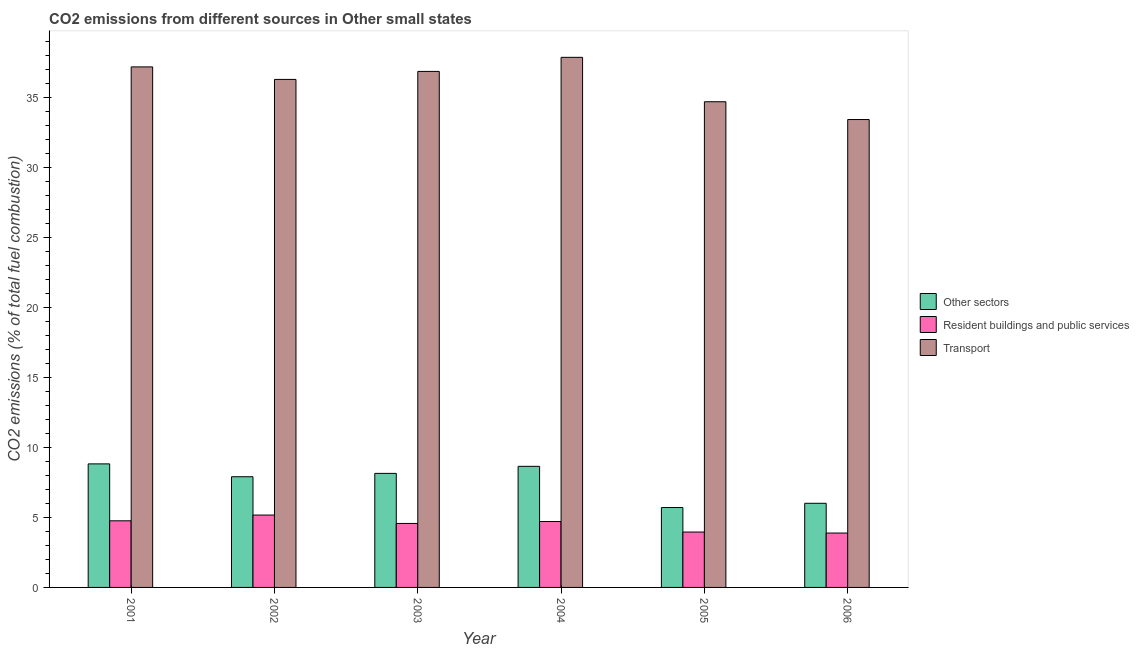How many bars are there on the 1st tick from the left?
Offer a very short reply. 3. What is the label of the 6th group of bars from the left?
Keep it short and to the point. 2006. What is the percentage of co2 emissions from resident buildings and public services in 2003?
Ensure brevity in your answer.  4.57. Across all years, what is the maximum percentage of co2 emissions from other sectors?
Provide a short and direct response. 8.82. Across all years, what is the minimum percentage of co2 emissions from transport?
Offer a terse response. 33.41. In which year was the percentage of co2 emissions from transport maximum?
Your answer should be compact. 2004. In which year was the percentage of co2 emissions from other sectors minimum?
Ensure brevity in your answer.  2005. What is the total percentage of co2 emissions from other sectors in the graph?
Ensure brevity in your answer.  45.22. What is the difference between the percentage of co2 emissions from other sectors in 2002 and that in 2005?
Your response must be concise. 2.2. What is the difference between the percentage of co2 emissions from resident buildings and public services in 2001 and the percentage of co2 emissions from transport in 2005?
Provide a succinct answer. 0.8. What is the average percentage of co2 emissions from transport per year?
Ensure brevity in your answer.  36.04. What is the ratio of the percentage of co2 emissions from resident buildings and public services in 2004 to that in 2006?
Your response must be concise. 1.21. Is the difference between the percentage of co2 emissions from resident buildings and public services in 2003 and 2004 greater than the difference between the percentage of co2 emissions from other sectors in 2003 and 2004?
Your answer should be very brief. No. What is the difference between the highest and the second highest percentage of co2 emissions from other sectors?
Offer a very short reply. 0.18. What is the difference between the highest and the lowest percentage of co2 emissions from other sectors?
Your response must be concise. 3.12. Is the sum of the percentage of co2 emissions from transport in 2002 and 2004 greater than the maximum percentage of co2 emissions from other sectors across all years?
Provide a short and direct response. Yes. What does the 3rd bar from the left in 2001 represents?
Give a very brief answer. Transport. What does the 2nd bar from the right in 2001 represents?
Keep it short and to the point. Resident buildings and public services. Are all the bars in the graph horizontal?
Provide a succinct answer. No. Are the values on the major ticks of Y-axis written in scientific E-notation?
Offer a very short reply. No. Where does the legend appear in the graph?
Your answer should be compact. Center right. What is the title of the graph?
Make the answer very short. CO2 emissions from different sources in Other small states. Does "Taxes on international trade" appear as one of the legend labels in the graph?
Provide a short and direct response. No. What is the label or title of the X-axis?
Provide a succinct answer. Year. What is the label or title of the Y-axis?
Provide a succinct answer. CO2 emissions (% of total fuel combustion). What is the CO2 emissions (% of total fuel combustion) of Other sectors in 2001?
Make the answer very short. 8.82. What is the CO2 emissions (% of total fuel combustion) of Resident buildings and public services in 2001?
Make the answer very short. 4.76. What is the CO2 emissions (% of total fuel combustion) of Transport in 2001?
Your answer should be very brief. 37.17. What is the CO2 emissions (% of total fuel combustion) of Other sectors in 2002?
Provide a short and direct response. 7.9. What is the CO2 emissions (% of total fuel combustion) in Resident buildings and public services in 2002?
Make the answer very short. 5.17. What is the CO2 emissions (% of total fuel combustion) in Transport in 2002?
Keep it short and to the point. 36.27. What is the CO2 emissions (% of total fuel combustion) of Other sectors in 2003?
Your answer should be compact. 8.14. What is the CO2 emissions (% of total fuel combustion) of Resident buildings and public services in 2003?
Offer a terse response. 4.57. What is the CO2 emissions (% of total fuel combustion) of Transport in 2003?
Keep it short and to the point. 36.84. What is the CO2 emissions (% of total fuel combustion) in Other sectors in 2004?
Your response must be concise. 8.65. What is the CO2 emissions (% of total fuel combustion) in Resident buildings and public services in 2004?
Your response must be concise. 4.71. What is the CO2 emissions (% of total fuel combustion) of Transport in 2004?
Keep it short and to the point. 37.85. What is the CO2 emissions (% of total fuel combustion) of Other sectors in 2005?
Offer a terse response. 5.7. What is the CO2 emissions (% of total fuel combustion) in Resident buildings and public services in 2005?
Your answer should be very brief. 3.95. What is the CO2 emissions (% of total fuel combustion) in Transport in 2005?
Provide a short and direct response. 34.68. What is the CO2 emissions (% of total fuel combustion) of Other sectors in 2006?
Provide a succinct answer. 6.01. What is the CO2 emissions (% of total fuel combustion) in Resident buildings and public services in 2006?
Offer a terse response. 3.88. What is the CO2 emissions (% of total fuel combustion) in Transport in 2006?
Offer a terse response. 33.41. Across all years, what is the maximum CO2 emissions (% of total fuel combustion) of Other sectors?
Offer a terse response. 8.82. Across all years, what is the maximum CO2 emissions (% of total fuel combustion) of Resident buildings and public services?
Offer a terse response. 5.17. Across all years, what is the maximum CO2 emissions (% of total fuel combustion) in Transport?
Your answer should be very brief. 37.85. Across all years, what is the minimum CO2 emissions (% of total fuel combustion) of Other sectors?
Make the answer very short. 5.7. Across all years, what is the minimum CO2 emissions (% of total fuel combustion) in Resident buildings and public services?
Ensure brevity in your answer.  3.88. Across all years, what is the minimum CO2 emissions (% of total fuel combustion) in Transport?
Your answer should be compact. 33.41. What is the total CO2 emissions (% of total fuel combustion) in Other sectors in the graph?
Give a very brief answer. 45.22. What is the total CO2 emissions (% of total fuel combustion) in Resident buildings and public services in the graph?
Offer a very short reply. 27.04. What is the total CO2 emissions (% of total fuel combustion) in Transport in the graph?
Your answer should be very brief. 216.21. What is the difference between the CO2 emissions (% of total fuel combustion) of Other sectors in 2001 and that in 2002?
Offer a terse response. 0.92. What is the difference between the CO2 emissions (% of total fuel combustion) of Resident buildings and public services in 2001 and that in 2002?
Keep it short and to the point. -0.41. What is the difference between the CO2 emissions (% of total fuel combustion) in Transport in 2001 and that in 2002?
Your answer should be compact. 0.89. What is the difference between the CO2 emissions (% of total fuel combustion) in Other sectors in 2001 and that in 2003?
Make the answer very short. 0.68. What is the difference between the CO2 emissions (% of total fuel combustion) in Resident buildings and public services in 2001 and that in 2003?
Make the answer very short. 0.19. What is the difference between the CO2 emissions (% of total fuel combustion) in Transport in 2001 and that in 2003?
Keep it short and to the point. 0.32. What is the difference between the CO2 emissions (% of total fuel combustion) in Other sectors in 2001 and that in 2004?
Give a very brief answer. 0.18. What is the difference between the CO2 emissions (% of total fuel combustion) of Resident buildings and public services in 2001 and that in 2004?
Make the answer very short. 0.05. What is the difference between the CO2 emissions (% of total fuel combustion) in Transport in 2001 and that in 2004?
Keep it short and to the point. -0.68. What is the difference between the CO2 emissions (% of total fuel combustion) in Other sectors in 2001 and that in 2005?
Offer a very short reply. 3.12. What is the difference between the CO2 emissions (% of total fuel combustion) in Resident buildings and public services in 2001 and that in 2005?
Ensure brevity in your answer.  0.8. What is the difference between the CO2 emissions (% of total fuel combustion) of Transport in 2001 and that in 2005?
Offer a terse response. 2.49. What is the difference between the CO2 emissions (% of total fuel combustion) of Other sectors in 2001 and that in 2006?
Offer a terse response. 2.81. What is the difference between the CO2 emissions (% of total fuel combustion) of Resident buildings and public services in 2001 and that in 2006?
Provide a succinct answer. 0.87. What is the difference between the CO2 emissions (% of total fuel combustion) of Transport in 2001 and that in 2006?
Your answer should be very brief. 3.76. What is the difference between the CO2 emissions (% of total fuel combustion) in Other sectors in 2002 and that in 2003?
Provide a short and direct response. -0.24. What is the difference between the CO2 emissions (% of total fuel combustion) of Resident buildings and public services in 2002 and that in 2003?
Your answer should be very brief. 0.6. What is the difference between the CO2 emissions (% of total fuel combustion) in Transport in 2002 and that in 2003?
Provide a short and direct response. -0.57. What is the difference between the CO2 emissions (% of total fuel combustion) of Other sectors in 2002 and that in 2004?
Provide a succinct answer. -0.74. What is the difference between the CO2 emissions (% of total fuel combustion) of Resident buildings and public services in 2002 and that in 2004?
Keep it short and to the point. 0.46. What is the difference between the CO2 emissions (% of total fuel combustion) in Transport in 2002 and that in 2004?
Provide a succinct answer. -1.58. What is the difference between the CO2 emissions (% of total fuel combustion) in Other sectors in 2002 and that in 2005?
Make the answer very short. 2.2. What is the difference between the CO2 emissions (% of total fuel combustion) of Resident buildings and public services in 2002 and that in 2005?
Your response must be concise. 1.21. What is the difference between the CO2 emissions (% of total fuel combustion) of Transport in 2002 and that in 2005?
Keep it short and to the point. 1.59. What is the difference between the CO2 emissions (% of total fuel combustion) of Other sectors in 2002 and that in 2006?
Give a very brief answer. 1.9. What is the difference between the CO2 emissions (% of total fuel combustion) of Resident buildings and public services in 2002 and that in 2006?
Give a very brief answer. 1.28. What is the difference between the CO2 emissions (% of total fuel combustion) in Transport in 2002 and that in 2006?
Your response must be concise. 2.86. What is the difference between the CO2 emissions (% of total fuel combustion) of Other sectors in 2003 and that in 2004?
Make the answer very short. -0.5. What is the difference between the CO2 emissions (% of total fuel combustion) in Resident buildings and public services in 2003 and that in 2004?
Keep it short and to the point. -0.14. What is the difference between the CO2 emissions (% of total fuel combustion) in Transport in 2003 and that in 2004?
Your answer should be compact. -1.01. What is the difference between the CO2 emissions (% of total fuel combustion) in Other sectors in 2003 and that in 2005?
Offer a terse response. 2.44. What is the difference between the CO2 emissions (% of total fuel combustion) in Resident buildings and public services in 2003 and that in 2005?
Ensure brevity in your answer.  0.61. What is the difference between the CO2 emissions (% of total fuel combustion) of Transport in 2003 and that in 2005?
Offer a very short reply. 2.17. What is the difference between the CO2 emissions (% of total fuel combustion) in Other sectors in 2003 and that in 2006?
Make the answer very short. 2.14. What is the difference between the CO2 emissions (% of total fuel combustion) in Resident buildings and public services in 2003 and that in 2006?
Your answer should be very brief. 0.69. What is the difference between the CO2 emissions (% of total fuel combustion) in Transport in 2003 and that in 2006?
Offer a terse response. 3.44. What is the difference between the CO2 emissions (% of total fuel combustion) of Other sectors in 2004 and that in 2005?
Your response must be concise. 2.94. What is the difference between the CO2 emissions (% of total fuel combustion) of Resident buildings and public services in 2004 and that in 2005?
Keep it short and to the point. 0.75. What is the difference between the CO2 emissions (% of total fuel combustion) in Transport in 2004 and that in 2005?
Provide a short and direct response. 3.17. What is the difference between the CO2 emissions (% of total fuel combustion) in Other sectors in 2004 and that in 2006?
Your response must be concise. 2.64. What is the difference between the CO2 emissions (% of total fuel combustion) in Resident buildings and public services in 2004 and that in 2006?
Your answer should be very brief. 0.82. What is the difference between the CO2 emissions (% of total fuel combustion) of Transport in 2004 and that in 2006?
Offer a terse response. 4.44. What is the difference between the CO2 emissions (% of total fuel combustion) in Other sectors in 2005 and that in 2006?
Give a very brief answer. -0.3. What is the difference between the CO2 emissions (% of total fuel combustion) of Resident buildings and public services in 2005 and that in 2006?
Give a very brief answer. 0.07. What is the difference between the CO2 emissions (% of total fuel combustion) in Transport in 2005 and that in 2006?
Make the answer very short. 1.27. What is the difference between the CO2 emissions (% of total fuel combustion) in Other sectors in 2001 and the CO2 emissions (% of total fuel combustion) in Resident buildings and public services in 2002?
Provide a short and direct response. 3.65. What is the difference between the CO2 emissions (% of total fuel combustion) in Other sectors in 2001 and the CO2 emissions (% of total fuel combustion) in Transport in 2002?
Your answer should be very brief. -27.45. What is the difference between the CO2 emissions (% of total fuel combustion) of Resident buildings and public services in 2001 and the CO2 emissions (% of total fuel combustion) of Transport in 2002?
Provide a succinct answer. -31.51. What is the difference between the CO2 emissions (% of total fuel combustion) of Other sectors in 2001 and the CO2 emissions (% of total fuel combustion) of Resident buildings and public services in 2003?
Your answer should be compact. 4.25. What is the difference between the CO2 emissions (% of total fuel combustion) in Other sectors in 2001 and the CO2 emissions (% of total fuel combustion) in Transport in 2003?
Your answer should be very brief. -28.02. What is the difference between the CO2 emissions (% of total fuel combustion) of Resident buildings and public services in 2001 and the CO2 emissions (% of total fuel combustion) of Transport in 2003?
Your response must be concise. -32.08. What is the difference between the CO2 emissions (% of total fuel combustion) of Other sectors in 2001 and the CO2 emissions (% of total fuel combustion) of Resident buildings and public services in 2004?
Offer a terse response. 4.11. What is the difference between the CO2 emissions (% of total fuel combustion) in Other sectors in 2001 and the CO2 emissions (% of total fuel combustion) in Transport in 2004?
Your answer should be compact. -29.03. What is the difference between the CO2 emissions (% of total fuel combustion) of Resident buildings and public services in 2001 and the CO2 emissions (% of total fuel combustion) of Transport in 2004?
Make the answer very short. -33.09. What is the difference between the CO2 emissions (% of total fuel combustion) of Other sectors in 2001 and the CO2 emissions (% of total fuel combustion) of Resident buildings and public services in 2005?
Your answer should be very brief. 4.87. What is the difference between the CO2 emissions (% of total fuel combustion) of Other sectors in 2001 and the CO2 emissions (% of total fuel combustion) of Transport in 2005?
Provide a succinct answer. -25.86. What is the difference between the CO2 emissions (% of total fuel combustion) of Resident buildings and public services in 2001 and the CO2 emissions (% of total fuel combustion) of Transport in 2005?
Give a very brief answer. -29.92. What is the difference between the CO2 emissions (% of total fuel combustion) in Other sectors in 2001 and the CO2 emissions (% of total fuel combustion) in Resident buildings and public services in 2006?
Your answer should be very brief. 4.94. What is the difference between the CO2 emissions (% of total fuel combustion) of Other sectors in 2001 and the CO2 emissions (% of total fuel combustion) of Transport in 2006?
Offer a terse response. -24.59. What is the difference between the CO2 emissions (% of total fuel combustion) of Resident buildings and public services in 2001 and the CO2 emissions (% of total fuel combustion) of Transport in 2006?
Offer a very short reply. -28.65. What is the difference between the CO2 emissions (% of total fuel combustion) in Other sectors in 2002 and the CO2 emissions (% of total fuel combustion) in Resident buildings and public services in 2003?
Your answer should be compact. 3.33. What is the difference between the CO2 emissions (% of total fuel combustion) of Other sectors in 2002 and the CO2 emissions (% of total fuel combustion) of Transport in 2003?
Your answer should be very brief. -28.94. What is the difference between the CO2 emissions (% of total fuel combustion) in Resident buildings and public services in 2002 and the CO2 emissions (% of total fuel combustion) in Transport in 2003?
Provide a short and direct response. -31.67. What is the difference between the CO2 emissions (% of total fuel combustion) in Other sectors in 2002 and the CO2 emissions (% of total fuel combustion) in Resident buildings and public services in 2004?
Your response must be concise. 3.2. What is the difference between the CO2 emissions (% of total fuel combustion) of Other sectors in 2002 and the CO2 emissions (% of total fuel combustion) of Transport in 2004?
Make the answer very short. -29.95. What is the difference between the CO2 emissions (% of total fuel combustion) of Resident buildings and public services in 2002 and the CO2 emissions (% of total fuel combustion) of Transport in 2004?
Provide a short and direct response. -32.68. What is the difference between the CO2 emissions (% of total fuel combustion) of Other sectors in 2002 and the CO2 emissions (% of total fuel combustion) of Resident buildings and public services in 2005?
Ensure brevity in your answer.  3.95. What is the difference between the CO2 emissions (% of total fuel combustion) in Other sectors in 2002 and the CO2 emissions (% of total fuel combustion) in Transport in 2005?
Ensure brevity in your answer.  -26.77. What is the difference between the CO2 emissions (% of total fuel combustion) in Resident buildings and public services in 2002 and the CO2 emissions (% of total fuel combustion) in Transport in 2005?
Offer a very short reply. -29.51. What is the difference between the CO2 emissions (% of total fuel combustion) of Other sectors in 2002 and the CO2 emissions (% of total fuel combustion) of Resident buildings and public services in 2006?
Ensure brevity in your answer.  4.02. What is the difference between the CO2 emissions (% of total fuel combustion) of Other sectors in 2002 and the CO2 emissions (% of total fuel combustion) of Transport in 2006?
Offer a very short reply. -25.5. What is the difference between the CO2 emissions (% of total fuel combustion) in Resident buildings and public services in 2002 and the CO2 emissions (% of total fuel combustion) in Transport in 2006?
Keep it short and to the point. -28.24. What is the difference between the CO2 emissions (% of total fuel combustion) in Other sectors in 2003 and the CO2 emissions (% of total fuel combustion) in Resident buildings and public services in 2004?
Make the answer very short. 3.44. What is the difference between the CO2 emissions (% of total fuel combustion) in Other sectors in 2003 and the CO2 emissions (% of total fuel combustion) in Transport in 2004?
Provide a short and direct response. -29.71. What is the difference between the CO2 emissions (% of total fuel combustion) of Resident buildings and public services in 2003 and the CO2 emissions (% of total fuel combustion) of Transport in 2004?
Ensure brevity in your answer.  -33.28. What is the difference between the CO2 emissions (% of total fuel combustion) in Other sectors in 2003 and the CO2 emissions (% of total fuel combustion) in Resident buildings and public services in 2005?
Give a very brief answer. 4.19. What is the difference between the CO2 emissions (% of total fuel combustion) of Other sectors in 2003 and the CO2 emissions (% of total fuel combustion) of Transport in 2005?
Ensure brevity in your answer.  -26.53. What is the difference between the CO2 emissions (% of total fuel combustion) in Resident buildings and public services in 2003 and the CO2 emissions (% of total fuel combustion) in Transport in 2005?
Provide a succinct answer. -30.11. What is the difference between the CO2 emissions (% of total fuel combustion) in Other sectors in 2003 and the CO2 emissions (% of total fuel combustion) in Resident buildings and public services in 2006?
Keep it short and to the point. 4.26. What is the difference between the CO2 emissions (% of total fuel combustion) in Other sectors in 2003 and the CO2 emissions (% of total fuel combustion) in Transport in 2006?
Make the answer very short. -25.26. What is the difference between the CO2 emissions (% of total fuel combustion) of Resident buildings and public services in 2003 and the CO2 emissions (% of total fuel combustion) of Transport in 2006?
Make the answer very short. -28.84. What is the difference between the CO2 emissions (% of total fuel combustion) of Other sectors in 2004 and the CO2 emissions (% of total fuel combustion) of Resident buildings and public services in 2005?
Make the answer very short. 4.69. What is the difference between the CO2 emissions (% of total fuel combustion) in Other sectors in 2004 and the CO2 emissions (% of total fuel combustion) in Transport in 2005?
Offer a terse response. -26.03. What is the difference between the CO2 emissions (% of total fuel combustion) in Resident buildings and public services in 2004 and the CO2 emissions (% of total fuel combustion) in Transport in 2005?
Offer a very short reply. -29.97. What is the difference between the CO2 emissions (% of total fuel combustion) in Other sectors in 2004 and the CO2 emissions (% of total fuel combustion) in Resident buildings and public services in 2006?
Your answer should be very brief. 4.76. What is the difference between the CO2 emissions (% of total fuel combustion) in Other sectors in 2004 and the CO2 emissions (% of total fuel combustion) in Transport in 2006?
Make the answer very short. -24.76. What is the difference between the CO2 emissions (% of total fuel combustion) of Resident buildings and public services in 2004 and the CO2 emissions (% of total fuel combustion) of Transport in 2006?
Provide a succinct answer. -28.7. What is the difference between the CO2 emissions (% of total fuel combustion) in Other sectors in 2005 and the CO2 emissions (% of total fuel combustion) in Resident buildings and public services in 2006?
Keep it short and to the point. 1.82. What is the difference between the CO2 emissions (% of total fuel combustion) of Other sectors in 2005 and the CO2 emissions (% of total fuel combustion) of Transport in 2006?
Offer a terse response. -27.7. What is the difference between the CO2 emissions (% of total fuel combustion) of Resident buildings and public services in 2005 and the CO2 emissions (% of total fuel combustion) of Transport in 2006?
Provide a short and direct response. -29.45. What is the average CO2 emissions (% of total fuel combustion) in Other sectors per year?
Your answer should be compact. 7.54. What is the average CO2 emissions (% of total fuel combustion) of Resident buildings and public services per year?
Your response must be concise. 4.51. What is the average CO2 emissions (% of total fuel combustion) in Transport per year?
Ensure brevity in your answer.  36.04. In the year 2001, what is the difference between the CO2 emissions (% of total fuel combustion) of Other sectors and CO2 emissions (% of total fuel combustion) of Resident buildings and public services?
Provide a succinct answer. 4.06. In the year 2001, what is the difference between the CO2 emissions (% of total fuel combustion) of Other sectors and CO2 emissions (% of total fuel combustion) of Transport?
Offer a very short reply. -28.34. In the year 2001, what is the difference between the CO2 emissions (% of total fuel combustion) of Resident buildings and public services and CO2 emissions (% of total fuel combustion) of Transport?
Make the answer very short. -32.41. In the year 2002, what is the difference between the CO2 emissions (% of total fuel combustion) in Other sectors and CO2 emissions (% of total fuel combustion) in Resident buildings and public services?
Your response must be concise. 2.74. In the year 2002, what is the difference between the CO2 emissions (% of total fuel combustion) in Other sectors and CO2 emissions (% of total fuel combustion) in Transport?
Ensure brevity in your answer.  -28.37. In the year 2002, what is the difference between the CO2 emissions (% of total fuel combustion) of Resident buildings and public services and CO2 emissions (% of total fuel combustion) of Transport?
Offer a terse response. -31.1. In the year 2003, what is the difference between the CO2 emissions (% of total fuel combustion) in Other sectors and CO2 emissions (% of total fuel combustion) in Resident buildings and public services?
Offer a terse response. 3.58. In the year 2003, what is the difference between the CO2 emissions (% of total fuel combustion) of Other sectors and CO2 emissions (% of total fuel combustion) of Transport?
Your answer should be very brief. -28.7. In the year 2003, what is the difference between the CO2 emissions (% of total fuel combustion) of Resident buildings and public services and CO2 emissions (% of total fuel combustion) of Transport?
Ensure brevity in your answer.  -32.27. In the year 2004, what is the difference between the CO2 emissions (% of total fuel combustion) in Other sectors and CO2 emissions (% of total fuel combustion) in Resident buildings and public services?
Give a very brief answer. 3.94. In the year 2004, what is the difference between the CO2 emissions (% of total fuel combustion) in Other sectors and CO2 emissions (% of total fuel combustion) in Transport?
Keep it short and to the point. -29.2. In the year 2004, what is the difference between the CO2 emissions (% of total fuel combustion) in Resident buildings and public services and CO2 emissions (% of total fuel combustion) in Transport?
Your answer should be very brief. -33.14. In the year 2005, what is the difference between the CO2 emissions (% of total fuel combustion) of Other sectors and CO2 emissions (% of total fuel combustion) of Resident buildings and public services?
Your answer should be very brief. 1.75. In the year 2005, what is the difference between the CO2 emissions (% of total fuel combustion) in Other sectors and CO2 emissions (% of total fuel combustion) in Transport?
Your response must be concise. -28.97. In the year 2005, what is the difference between the CO2 emissions (% of total fuel combustion) in Resident buildings and public services and CO2 emissions (% of total fuel combustion) in Transport?
Provide a short and direct response. -30.72. In the year 2006, what is the difference between the CO2 emissions (% of total fuel combustion) in Other sectors and CO2 emissions (% of total fuel combustion) in Resident buildings and public services?
Ensure brevity in your answer.  2.12. In the year 2006, what is the difference between the CO2 emissions (% of total fuel combustion) of Other sectors and CO2 emissions (% of total fuel combustion) of Transport?
Offer a very short reply. -27.4. In the year 2006, what is the difference between the CO2 emissions (% of total fuel combustion) of Resident buildings and public services and CO2 emissions (% of total fuel combustion) of Transport?
Offer a very short reply. -29.52. What is the ratio of the CO2 emissions (% of total fuel combustion) of Other sectors in 2001 to that in 2002?
Provide a succinct answer. 1.12. What is the ratio of the CO2 emissions (% of total fuel combustion) in Resident buildings and public services in 2001 to that in 2002?
Give a very brief answer. 0.92. What is the ratio of the CO2 emissions (% of total fuel combustion) of Transport in 2001 to that in 2002?
Your response must be concise. 1.02. What is the ratio of the CO2 emissions (% of total fuel combustion) of Other sectors in 2001 to that in 2003?
Keep it short and to the point. 1.08. What is the ratio of the CO2 emissions (% of total fuel combustion) of Resident buildings and public services in 2001 to that in 2003?
Offer a very short reply. 1.04. What is the ratio of the CO2 emissions (% of total fuel combustion) in Transport in 2001 to that in 2003?
Give a very brief answer. 1.01. What is the ratio of the CO2 emissions (% of total fuel combustion) of Other sectors in 2001 to that in 2004?
Your response must be concise. 1.02. What is the ratio of the CO2 emissions (% of total fuel combustion) in Resident buildings and public services in 2001 to that in 2004?
Your answer should be very brief. 1.01. What is the ratio of the CO2 emissions (% of total fuel combustion) of Transport in 2001 to that in 2004?
Give a very brief answer. 0.98. What is the ratio of the CO2 emissions (% of total fuel combustion) in Other sectors in 2001 to that in 2005?
Keep it short and to the point. 1.55. What is the ratio of the CO2 emissions (% of total fuel combustion) of Resident buildings and public services in 2001 to that in 2005?
Keep it short and to the point. 1.2. What is the ratio of the CO2 emissions (% of total fuel combustion) of Transport in 2001 to that in 2005?
Offer a terse response. 1.07. What is the ratio of the CO2 emissions (% of total fuel combustion) of Other sectors in 2001 to that in 2006?
Offer a terse response. 1.47. What is the ratio of the CO2 emissions (% of total fuel combustion) of Resident buildings and public services in 2001 to that in 2006?
Your answer should be compact. 1.23. What is the ratio of the CO2 emissions (% of total fuel combustion) of Transport in 2001 to that in 2006?
Your response must be concise. 1.11. What is the ratio of the CO2 emissions (% of total fuel combustion) in Other sectors in 2002 to that in 2003?
Keep it short and to the point. 0.97. What is the ratio of the CO2 emissions (% of total fuel combustion) in Resident buildings and public services in 2002 to that in 2003?
Provide a succinct answer. 1.13. What is the ratio of the CO2 emissions (% of total fuel combustion) of Transport in 2002 to that in 2003?
Provide a short and direct response. 0.98. What is the ratio of the CO2 emissions (% of total fuel combustion) of Other sectors in 2002 to that in 2004?
Offer a terse response. 0.91. What is the ratio of the CO2 emissions (% of total fuel combustion) in Resident buildings and public services in 2002 to that in 2004?
Make the answer very short. 1.1. What is the ratio of the CO2 emissions (% of total fuel combustion) in Other sectors in 2002 to that in 2005?
Provide a succinct answer. 1.39. What is the ratio of the CO2 emissions (% of total fuel combustion) of Resident buildings and public services in 2002 to that in 2005?
Provide a succinct answer. 1.31. What is the ratio of the CO2 emissions (% of total fuel combustion) of Transport in 2002 to that in 2005?
Offer a very short reply. 1.05. What is the ratio of the CO2 emissions (% of total fuel combustion) of Other sectors in 2002 to that in 2006?
Your response must be concise. 1.32. What is the ratio of the CO2 emissions (% of total fuel combustion) in Resident buildings and public services in 2002 to that in 2006?
Provide a short and direct response. 1.33. What is the ratio of the CO2 emissions (% of total fuel combustion) in Transport in 2002 to that in 2006?
Provide a short and direct response. 1.09. What is the ratio of the CO2 emissions (% of total fuel combustion) of Other sectors in 2003 to that in 2004?
Offer a very short reply. 0.94. What is the ratio of the CO2 emissions (% of total fuel combustion) of Resident buildings and public services in 2003 to that in 2004?
Provide a succinct answer. 0.97. What is the ratio of the CO2 emissions (% of total fuel combustion) in Transport in 2003 to that in 2004?
Offer a terse response. 0.97. What is the ratio of the CO2 emissions (% of total fuel combustion) in Other sectors in 2003 to that in 2005?
Keep it short and to the point. 1.43. What is the ratio of the CO2 emissions (% of total fuel combustion) of Resident buildings and public services in 2003 to that in 2005?
Give a very brief answer. 1.16. What is the ratio of the CO2 emissions (% of total fuel combustion) in Transport in 2003 to that in 2005?
Offer a terse response. 1.06. What is the ratio of the CO2 emissions (% of total fuel combustion) of Other sectors in 2003 to that in 2006?
Offer a terse response. 1.36. What is the ratio of the CO2 emissions (% of total fuel combustion) in Resident buildings and public services in 2003 to that in 2006?
Make the answer very short. 1.18. What is the ratio of the CO2 emissions (% of total fuel combustion) of Transport in 2003 to that in 2006?
Give a very brief answer. 1.1. What is the ratio of the CO2 emissions (% of total fuel combustion) of Other sectors in 2004 to that in 2005?
Provide a succinct answer. 1.52. What is the ratio of the CO2 emissions (% of total fuel combustion) of Resident buildings and public services in 2004 to that in 2005?
Give a very brief answer. 1.19. What is the ratio of the CO2 emissions (% of total fuel combustion) of Transport in 2004 to that in 2005?
Your response must be concise. 1.09. What is the ratio of the CO2 emissions (% of total fuel combustion) of Other sectors in 2004 to that in 2006?
Offer a very short reply. 1.44. What is the ratio of the CO2 emissions (% of total fuel combustion) in Resident buildings and public services in 2004 to that in 2006?
Keep it short and to the point. 1.21. What is the ratio of the CO2 emissions (% of total fuel combustion) of Transport in 2004 to that in 2006?
Make the answer very short. 1.13. What is the ratio of the CO2 emissions (% of total fuel combustion) in Other sectors in 2005 to that in 2006?
Offer a very short reply. 0.95. What is the ratio of the CO2 emissions (% of total fuel combustion) in Resident buildings and public services in 2005 to that in 2006?
Your response must be concise. 1.02. What is the ratio of the CO2 emissions (% of total fuel combustion) of Transport in 2005 to that in 2006?
Offer a terse response. 1.04. What is the difference between the highest and the second highest CO2 emissions (% of total fuel combustion) of Other sectors?
Ensure brevity in your answer.  0.18. What is the difference between the highest and the second highest CO2 emissions (% of total fuel combustion) in Resident buildings and public services?
Your answer should be compact. 0.41. What is the difference between the highest and the second highest CO2 emissions (% of total fuel combustion) in Transport?
Your answer should be very brief. 0.68. What is the difference between the highest and the lowest CO2 emissions (% of total fuel combustion) in Other sectors?
Provide a short and direct response. 3.12. What is the difference between the highest and the lowest CO2 emissions (% of total fuel combustion) of Resident buildings and public services?
Your answer should be compact. 1.28. What is the difference between the highest and the lowest CO2 emissions (% of total fuel combustion) of Transport?
Give a very brief answer. 4.44. 